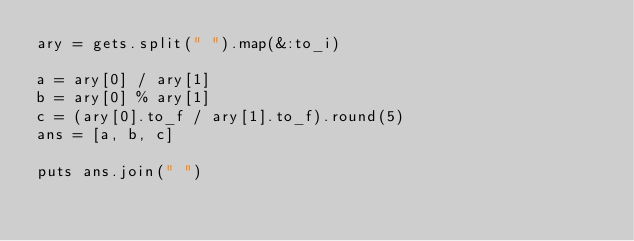Convert code to text. <code><loc_0><loc_0><loc_500><loc_500><_Ruby_>ary = gets.split(" ").map(&:to_i)

a = ary[0] / ary[1]
b = ary[0] % ary[1]
c = (ary[0].to_f / ary[1].to_f).round(5)
ans = [a, b, c]

puts ans.join(" ")</code> 